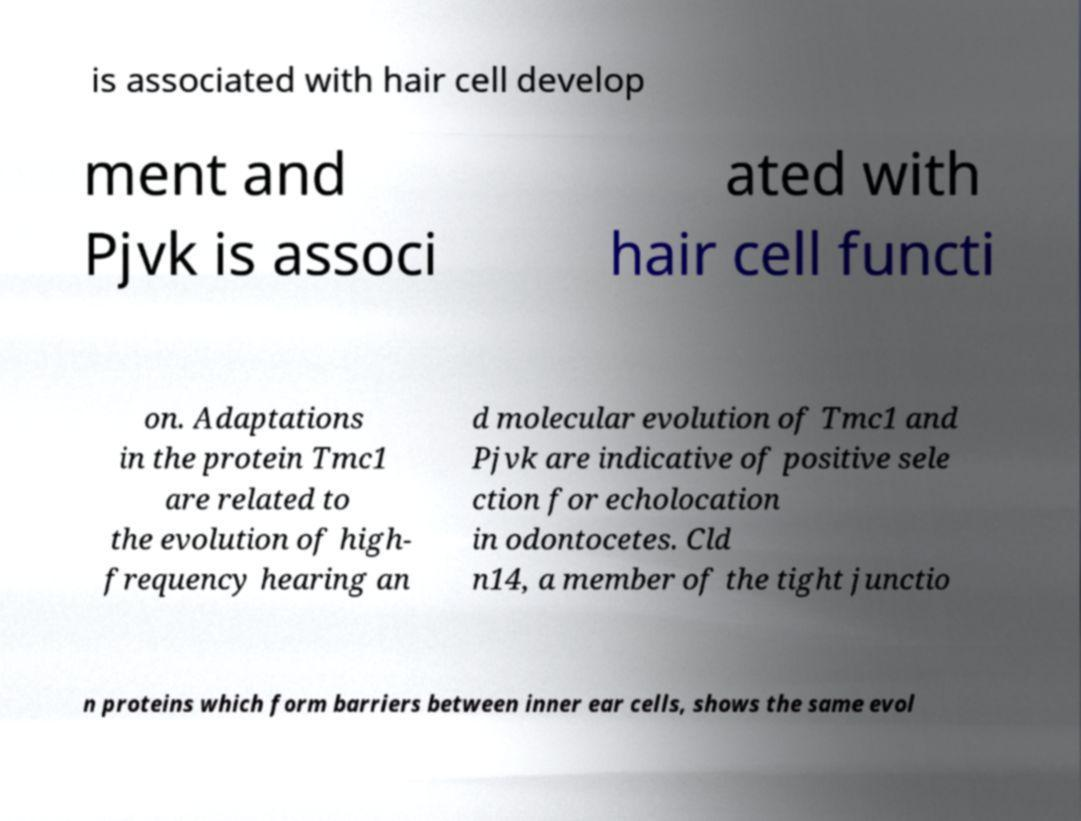Please identify and transcribe the text found in this image. is associated with hair cell develop ment and Pjvk is associ ated with hair cell functi on. Adaptations in the protein Tmc1 are related to the evolution of high- frequency hearing an d molecular evolution of Tmc1 and Pjvk are indicative of positive sele ction for echolocation in odontocetes. Cld n14, a member of the tight junctio n proteins which form barriers between inner ear cells, shows the same evol 